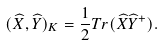<formula> <loc_0><loc_0><loc_500><loc_500>( { \widehat { X } } , { \widehat { Y } } ) _ { K } = \frac { 1 } { 2 } T r ( { \widehat { X } } { \widehat { Y } } ^ { + } ) .</formula> 